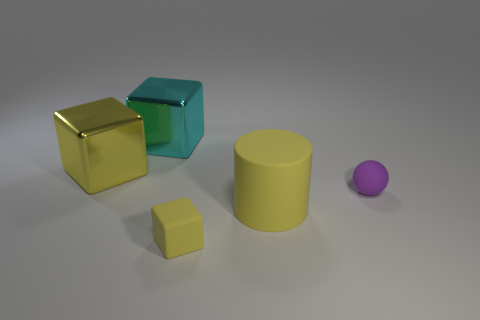Add 2 yellow objects. How many objects exist? 7 Subtract all spheres. How many objects are left? 4 Add 5 big yellow metallic blocks. How many big yellow metallic blocks are left? 6 Add 2 large cyan shiny cylinders. How many large cyan shiny cylinders exist? 2 Subtract 0 red cubes. How many objects are left? 5 Subtract all big rubber cylinders. Subtract all large cyan blocks. How many objects are left? 3 